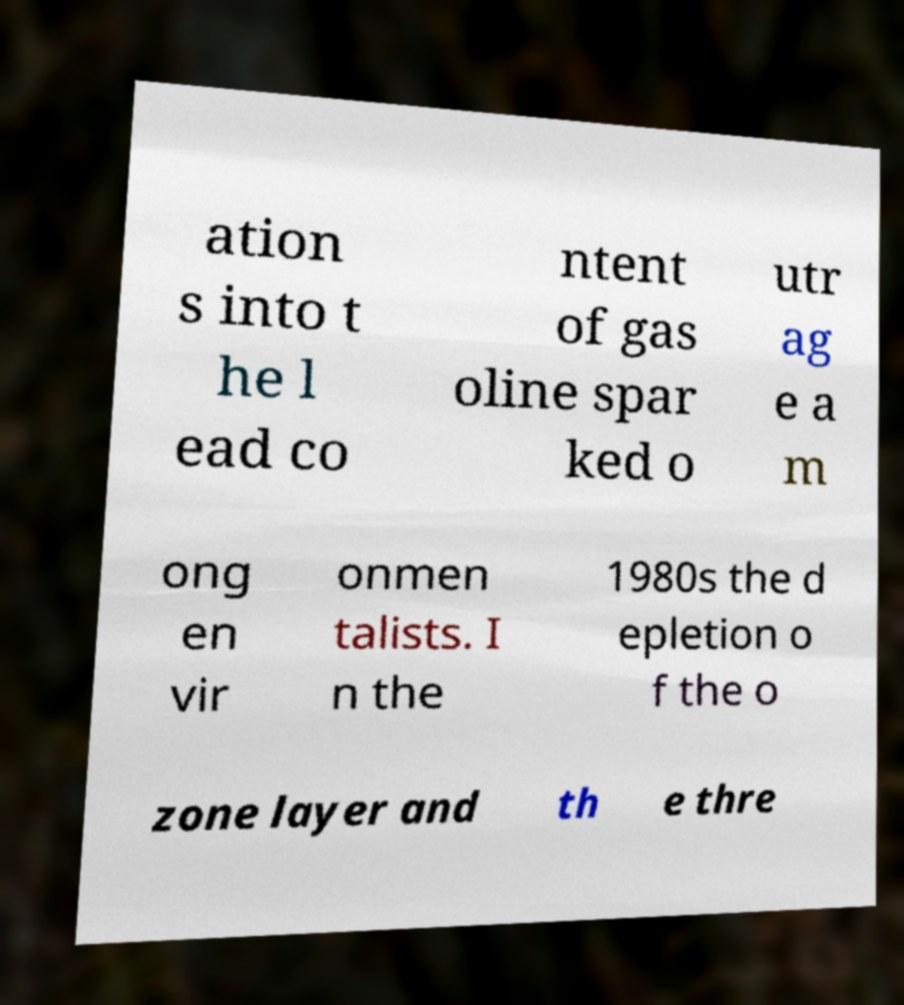Could you extract and type out the text from this image? ation s into t he l ead co ntent of gas oline spar ked o utr ag e a m ong en vir onmen talists. I n the 1980s the d epletion o f the o zone layer and th e thre 